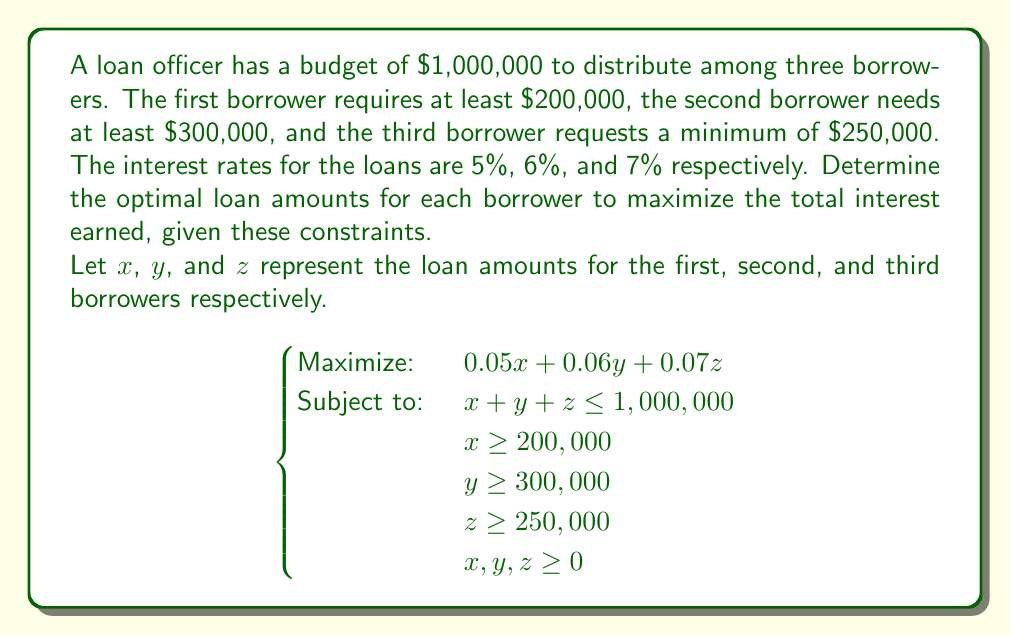Give your solution to this math problem. To solve this linear programming problem, we'll use the following steps:

1) First, observe that to maximize interest earned, we should allocate the entire budget of $1,000,000.

2) Given the interest rates, we should prioritize allocating money to the highest interest rate (7%), then the second highest (6%), and finally the lowest (5%).

3) Start by satisfying the minimum requirements:
   $x = 200,000$
   $y = 300,000$
   $z = 250,000$
   Total so far: $750,000

4) Remaining amount to allocate: $1,000,000 - 750,000 = 250,000$

5) Allocate the remaining $250,000 to the highest interest rate loan (z):
   $z = 250,000 + 250,000 = 500,000$

6) Final allocation:
   $x = 200,000$
   $y = 300,000$
   $z = 500,000$

7) Verify the total: $200,000 + 300,000 + 500,000 = 1,000,000$

8) Calculate the total interest earned:
   $(200,000 * 0.05) + (300,000 * 0.06) + (500,000 * 0.07)$
   $= 10,000 + 18,000 + 35,000$
   $= 63,000$

This allocation maximizes the interest earned while satisfying all constraints.
Answer: The optimal loan amounts are:
Borrower 1: $200,000
Borrower 2: $300,000
Borrower 3: $500,000

Total interest earned: $63,000 